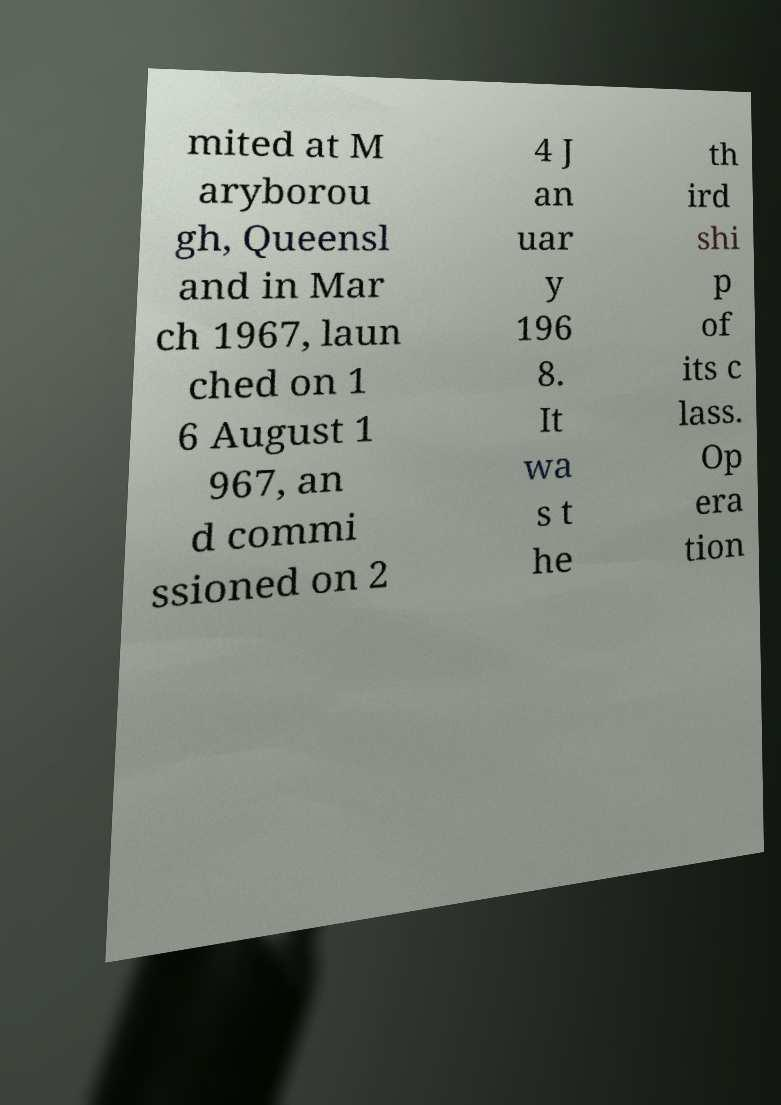Please identify and transcribe the text found in this image. mited at M aryborou gh, Queensl and in Mar ch 1967, laun ched on 1 6 August 1 967, an d commi ssioned on 2 4 J an uar y 196 8. It wa s t he th ird shi p of its c lass. Op era tion 